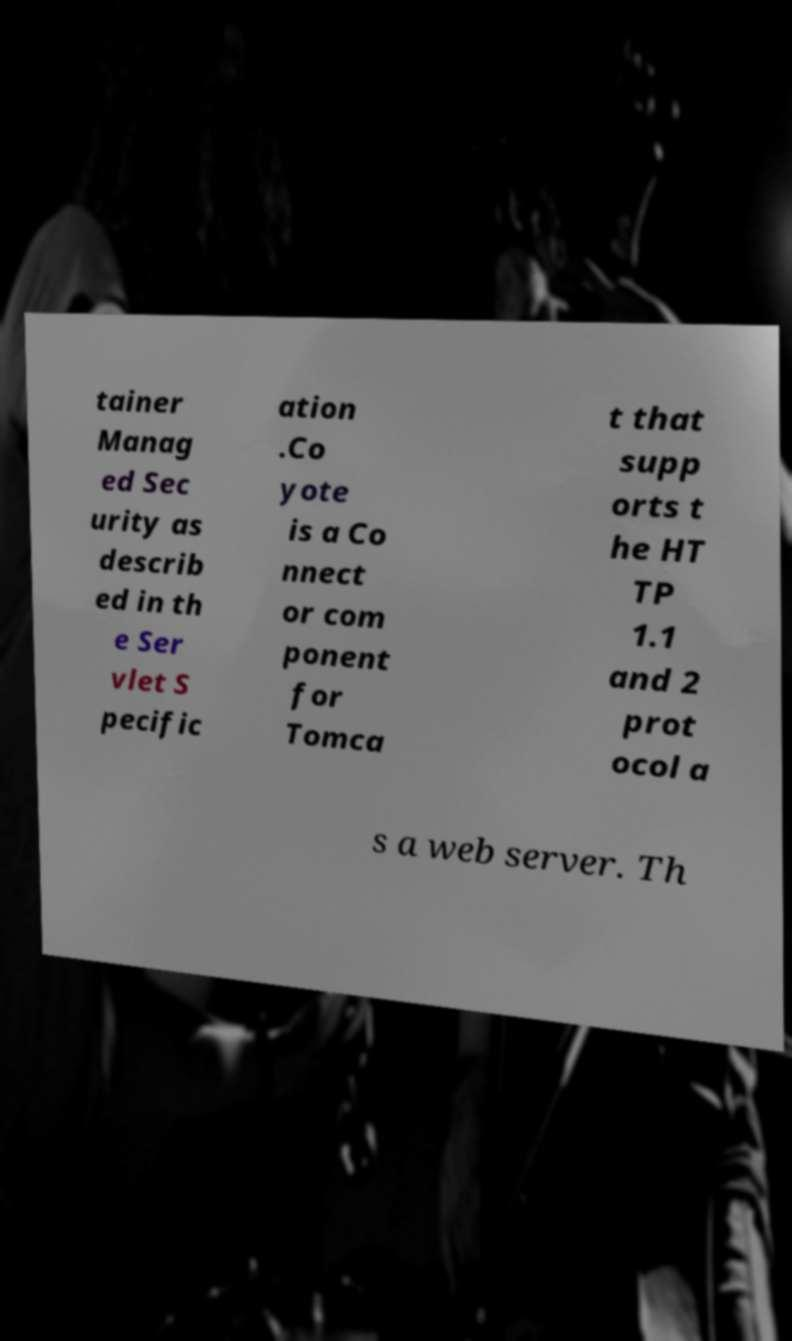Can you accurately transcribe the text from the provided image for me? tainer Manag ed Sec urity as describ ed in th e Ser vlet S pecific ation .Co yote is a Co nnect or com ponent for Tomca t that supp orts t he HT TP 1.1 and 2 prot ocol a s a web server. Th 